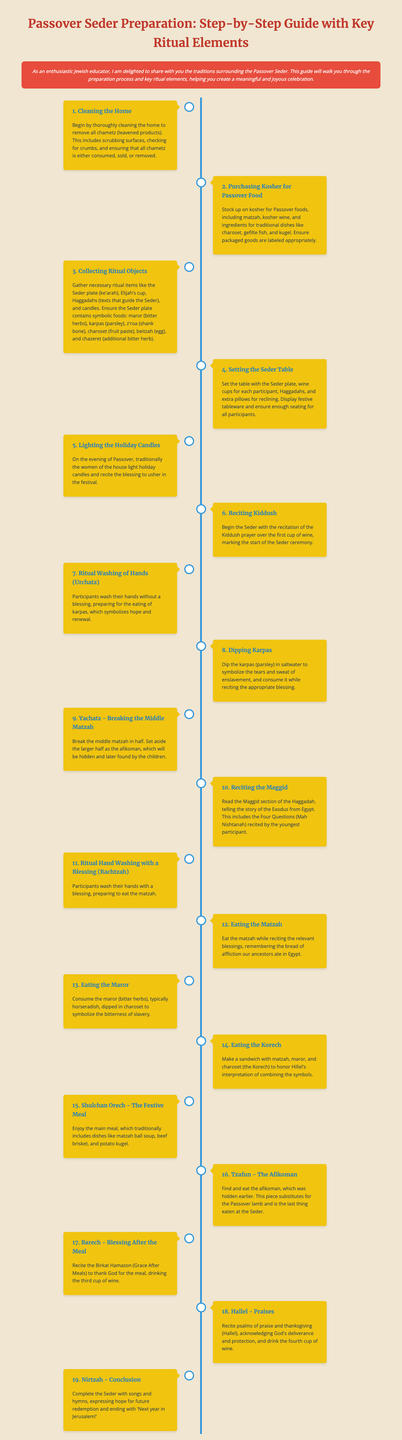What is the first step in the Seder preparation? The first step listed in the document is cleaning the home to remove all chametz.
Answer: Cleaning the Home What food is traditionally dipped in saltwater during the Seder? The document states that karpas (parsley) is dipped in saltwater during the Seder.
Answer: Karpas How many cups of wine are consumed during the Seder? According to the document, four cups of wine are consumed throughout the Seder.
Answer: Four What is the symbolic food added to the Seder plate that represents the Passover lamb? The afikoman, which substitutes for the Passover lamb, is mentioned as the last thing eaten at the Seder.
Answer: Afikoman What blessing is recited after the meal? The blessing after the meal mentioned in the document is the Birkat Hamazon.
Answer: Birkat Hamazon In which step is the Haggadah used? The Haggadah is used during the reciting of Maggid, where the story of the Exodus is read.
Answer: Reciting the Maggid What does the term "Nirtzah" refer to in the Seder? Nirtzah marks the conclusion of the Seder, where songs and hymns expressing hope for future redemption are sung.
Answer: Conclusion Which ritual involves washing hands without a blessing? The ritual washing of hands without a blessing is referred to as Urchatz.
Answer: Urchatz 